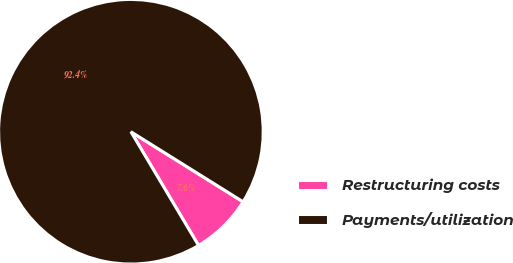<chart> <loc_0><loc_0><loc_500><loc_500><pie_chart><fcel>Restructuring costs<fcel>Payments/utilization<nl><fcel>7.58%<fcel>92.42%<nl></chart> 